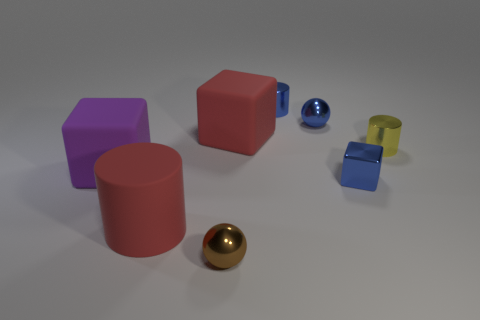What is the material of the large red object that is the same shape as the tiny yellow shiny object?
Ensure brevity in your answer.  Rubber. There is a red thing that is in front of the blue shiny object in front of the matte cube that is in front of the tiny yellow metallic cylinder; what is its material?
Ensure brevity in your answer.  Rubber. Is the color of the big object right of the rubber cylinder the same as the rubber object in front of the purple cube?
Keep it short and to the point. Yes. Is the size of the metal cylinder in front of the blue metallic ball the same as the red matte cylinder?
Keep it short and to the point. No. The rubber thing that is the same color as the large cylinder is what shape?
Keep it short and to the point. Cube. There is a small metal thing that is to the left of the tiny blue cylinder; what shape is it?
Ensure brevity in your answer.  Sphere. What number of big purple objects are the same shape as the tiny yellow object?
Provide a short and direct response. 0. There is a cylinder on the left side of the red rubber block to the right of the red matte cylinder; what size is it?
Your answer should be very brief. Large. What number of blue objects are either big rubber cylinders or tiny shiny cylinders?
Provide a short and direct response. 1. Are there fewer small brown spheres that are right of the small yellow shiny object than brown things in front of the small blue cylinder?
Offer a very short reply. Yes. 